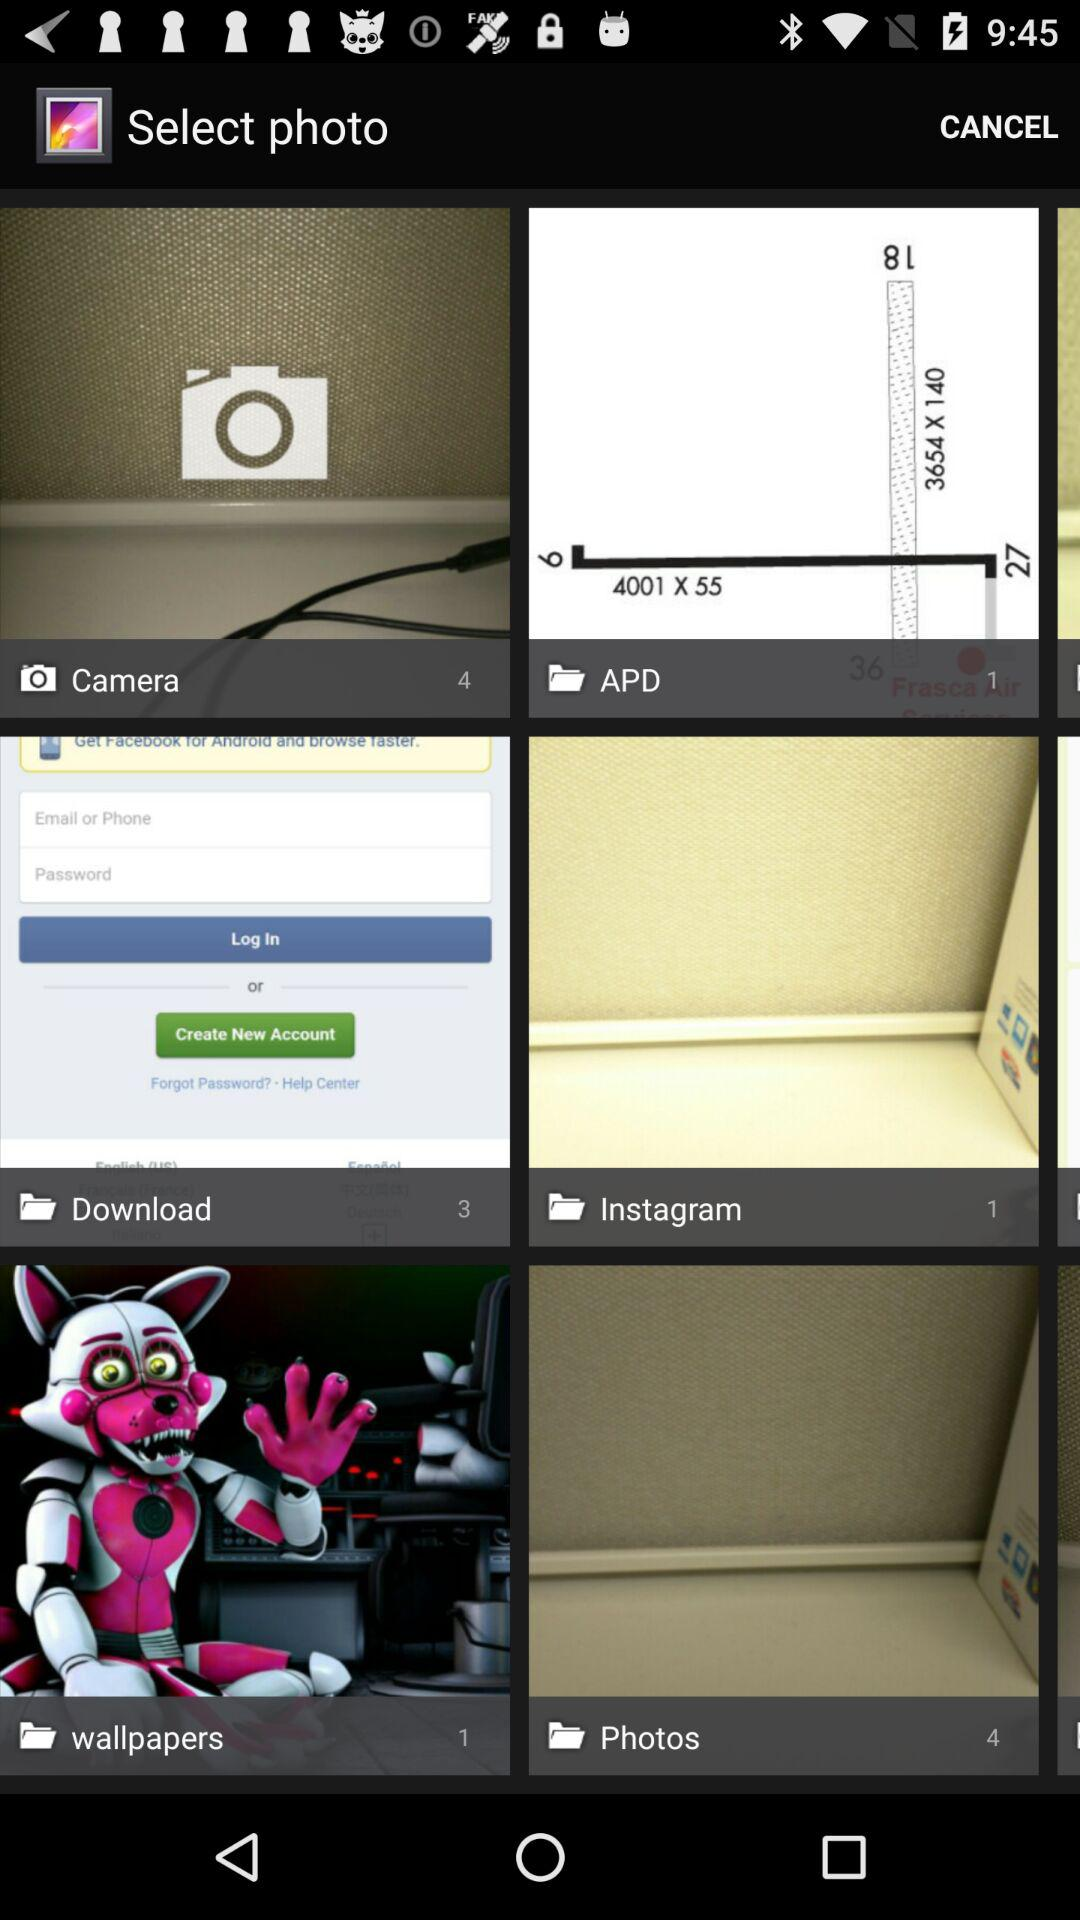How many pictures are in the "APD" folder? There is 1 picture. 